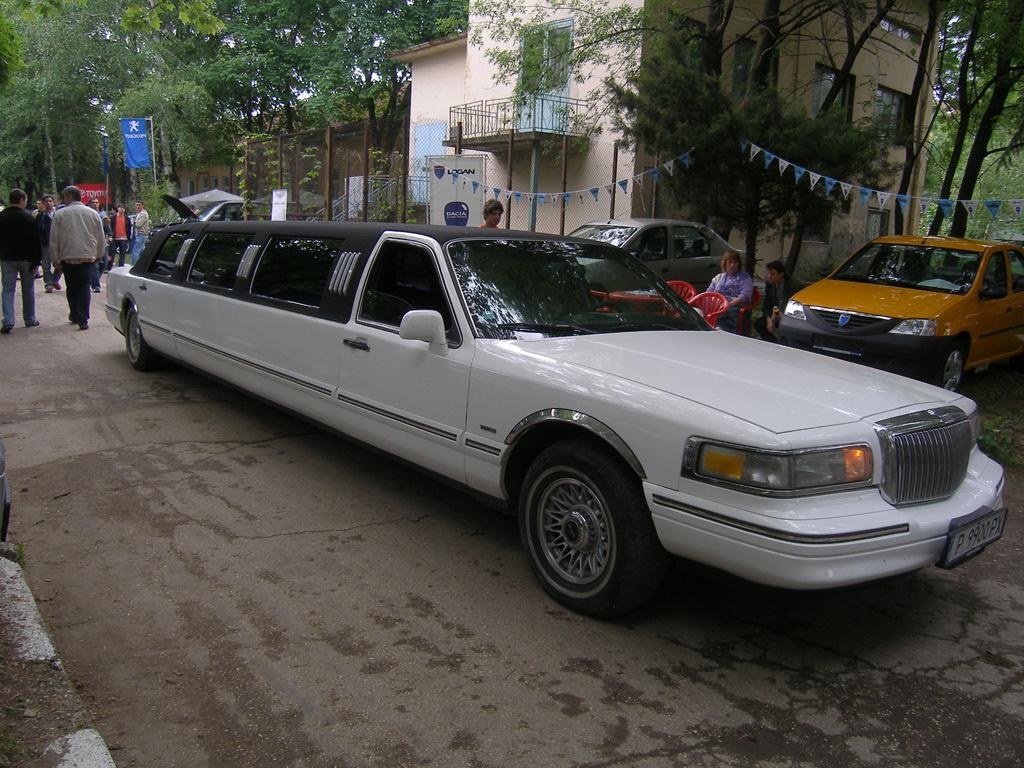What is happening in the foreground of the image? There are cars on a road in the image. What can be seen in the background of the image? There is a house, trees, and people in the background of the image. Can you describe the woman in the image? There is a woman sitting on a chair in the image. What type of account does the woman have with the bottle in the image? There is no bottle present in the image, and therefore no account can be associated with it. 